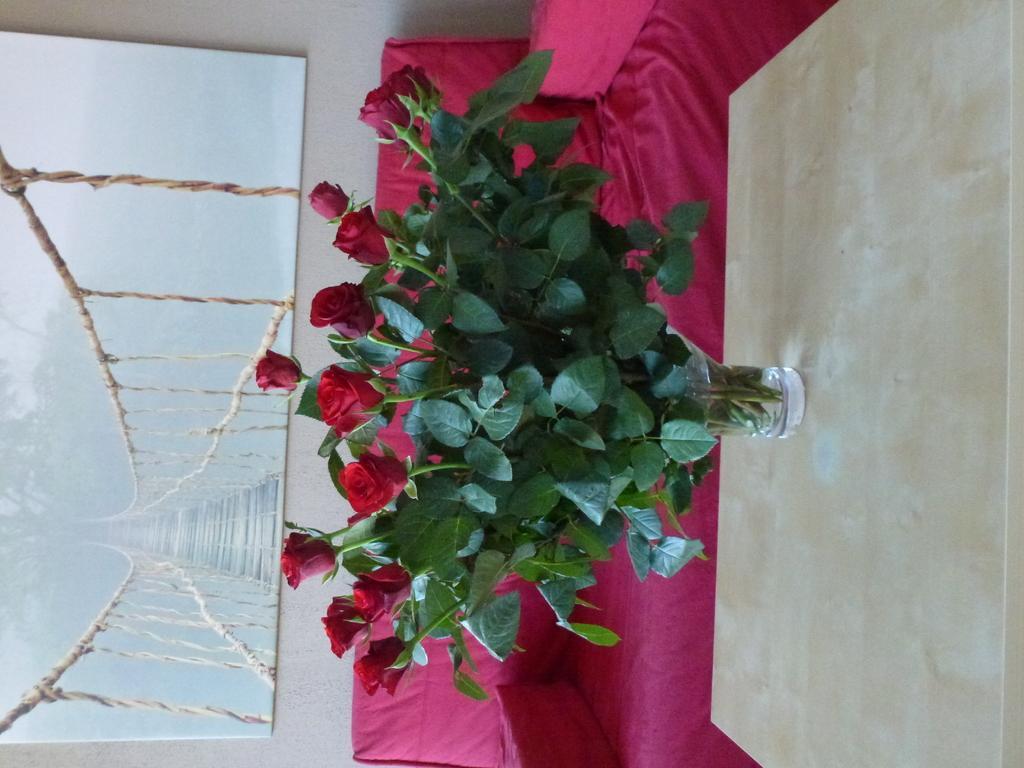In one or two sentences, can you explain what this image depicts? In this picture we can see a flower vase on the table and in the background we can see a sofa and a photo frame on the wall. 